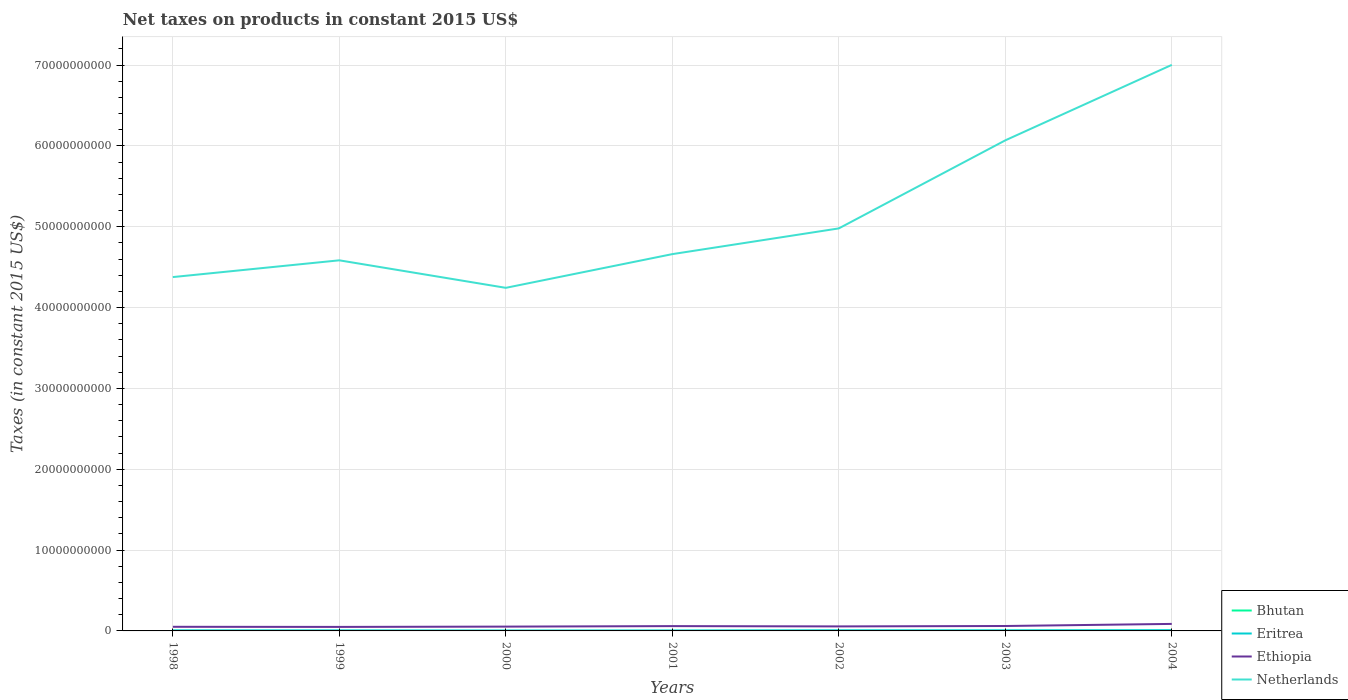How many different coloured lines are there?
Keep it short and to the point. 4. Is the number of lines equal to the number of legend labels?
Your response must be concise. Yes. Across all years, what is the maximum net taxes on products in Bhutan?
Keep it short and to the point. 9.43e+06. In which year was the net taxes on products in Ethiopia maximum?
Your answer should be compact. 1999. What is the total net taxes on products in Ethiopia in the graph?
Keep it short and to the point. 1.28e+07. What is the difference between the highest and the second highest net taxes on products in Ethiopia?
Your answer should be compact. 3.70e+08. What is the difference between the highest and the lowest net taxes on products in Eritrea?
Offer a very short reply. 3. Is the net taxes on products in Netherlands strictly greater than the net taxes on products in Eritrea over the years?
Give a very brief answer. No. How many lines are there?
Ensure brevity in your answer.  4. How many years are there in the graph?
Make the answer very short. 7. What is the difference between two consecutive major ticks on the Y-axis?
Your response must be concise. 1.00e+1. Are the values on the major ticks of Y-axis written in scientific E-notation?
Your response must be concise. No. Does the graph contain any zero values?
Ensure brevity in your answer.  No. How are the legend labels stacked?
Keep it short and to the point. Vertical. What is the title of the graph?
Ensure brevity in your answer.  Net taxes on products in constant 2015 US$. Does "Middle income" appear as one of the legend labels in the graph?
Your answer should be compact. No. What is the label or title of the X-axis?
Your answer should be very brief. Years. What is the label or title of the Y-axis?
Your answer should be very brief. Taxes (in constant 2015 US$). What is the Taxes (in constant 2015 US$) of Bhutan in 1998?
Your response must be concise. 1.32e+07. What is the Taxes (in constant 2015 US$) in Eritrea in 1998?
Offer a very short reply. 6.31e+07. What is the Taxes (in constant 2015 US$) in Ethiopia in 1998?
Provide a short and direct response. 5.10e+08. What is the Taxes (in constant 2015 US$) of Netherlands in 1998?
Make the answer very short. 4.38e+1. What is the Taxes (in constant 2015 US$) of Bhutan in 1999?
Your answer should be compact. 1.44e+07. What is the Taxes (in constant 2015 US$) in Eritrea in 1999?
Offer a very short reply. 5.98e+07. What is the Taxes (in constant 2015 US$) in Ethiopia in 1999?
Provide a succinct answer. 4.98e+08. What is the Taxes (in constant 2015 US$) of Netherlands in 1999?
Keep it short and to the point. 4.58e+1. What is the Taxes (in constant 2015 US$) of Bhutan in 2000?
Your answer should be very brief. 9.43e+06. What is the Taxes (in constant 2015 US$) of Eritrea in 2000?
Your response must be concise. 4.44e+07. What is the Taxes (in constant 2015 US$) of Ethiopia in 2000?
Provide a short and direct response. 5.34e+08. What is the Taxes (in constant 2015 US$) in Netherlands in 2000?
Provide a succinct answer. 4.24e+1. What is the Taxes (in constant 2015 US$) in Bhutan in 2001?
Provide a short and direct response. 1.02e+07. What is the Taxes (in constant 2015 US$) of Eritrea in 2001?
Make the answer very short. 5.02e+07. What is the Taxes (in constant 2015 US$) in Ethiopia in 2001?
Provide a short and direct response. 5.95e+08. What is the Taxes (in constant 2015 US$) of Netherlands in 2001?
Give a very brief answer. 4.66e+1. What is the Taxes (in constant 2015 US$) in Bhutan in 2002?
Provide a short and direct response. 1.68e+07. What is the Taxes (in constant 2015 US$) of Eritrea in 2002?
Offer a terse response. 7.06e+07. What is the Taxes (in constant 2015 US$) in Ethiopia in 2002?
Make the answer very short. 5.59e+08. What is the Taxes (in constant 2015 US$) in Netherlands in 2002?
Your response must be concise. 4.98e+1. What is the Taxes (in constant 2015 US$) in Bhutan in 2003?
Keep it short and to the point. 1.98e+07. What is the Taxes (in constant 2015 US$) of Eritrea in 2003?
Keep it short and to the point. 7.06e+07. What is the Taxes (in constant 2015 US$) of Ethiopia in 2003?
Make the answer very short. 6.09e+08. What is the Taxes (in constant 2015 US$) in Netherlands in 2003?
Offer a terse response. 6.07e+1. What is the Taxes (in constant 2015 US$) of Bhutan in 2004?
Offer a very short reply. 2.67e+07. What is the Taxes (in constant 2015 US$) of Eritrea in 2004?
Your answer should be compact. 8.94e+07. What is the Taxes (in constant 2015 US$) of Ethiopia in 2004?
Your response must be concise. 8.67e+08. What is the Taxes (in constant 2015 US$) of Netherlands in 2004?
Ensure brevity in your answer.  7.00e+1. Across all years, what is the maximum Taxes (in constant 2015 US$) of Bhutan?
Your response must be concise. 2.67e+07. Across all years, what is the maximum Taxes (in constant 2015 US$) in Eritrea?
Your response must be concise. 8.94e+07. Across all years, what is the maximum Taxes (in constant 2015 US$) in Ethiopia?
Keep it short and to the point. 8.67e+08. Across all years, what is the maximum Taxes (in constant 2015 US$) in Netherlands?
Provide a succinct answer. 7.00e+1. Across all years, what is the minimum Taxes (in constant 2015 US$) of Bhutan?
Provide a succinct answer. 9.43e+06. Across all years, what is the minimum Taxes (in constant 2015 US$) of Eritrea?
Provide a succinct answer. 4.44e+07. Across all years, what is the minimum Taxes (in constant 2015 US$) of Ethiopia?
Make the answer very short. 4.98e+08. Across all years, what is the minimum Taxes (in constant 2015 US$) of Netherlands?
Your answer should be very brief. 4.24e+1. What is the total Taxes (in constant 2015 US$) in Bhutan in the graph?
Your answer should be very brief. 1.11e+08. What is the total Taxes (in constant 2015 US$) in Eritrea in the graph?
Your answer should be very brief. 4.48e+08. What is the total Taxes (in constant 2015 US$) of Ethiopia in the graph?
Keep it short and to the point. 4.17e+09. What is the total Taxes (in constant 2015 US$) of Netherlands in the graph?
Make the answer very short. 3.59e+11. What is the difference between the Taxes (in constant 2015 US$) in Bhutan in 1998 and that in 1999?
Your answer should be compact. -1.19e+06. What is the difference between the Taxes (in constant 2015 US$) in Eritrea in 1998 and that in 1999?
Offer a very short reply. 3.34e+06. What is the difference between the Taxes (in constant 2015 US$) of Ethiopia in 1998 and that in 1999?
Provide a short and direct response. 1.28e+07. What is the difference between the Taxes (in constant 2015 US$) in Netherlands in 1998 and that in 1999?
Keep it short and to the point. -2.07e+09. What is the difference between the Taxes (in constant 2015 US$) in Bhutan in 1998 and that in 2000?
Provide a short and direct response. 3.80e+06. What is the difference between the Taxes (in constant 2015 US$) in Eritrea in 1998 and that in 2000?
Your answer should be compact. 1.87e+07. What is the difference between the Taxes (in constant 2015 US$) in Ethiopia in 1998 and that in 2000?
Keep it short and to the point. -2.34e+07. What is the difference between the Taxes (in constant 2015 US$) in Netherlands in 1998 and that in 2000?
Your response must be concise. 1.33e+09. What is the difference between the Taxes (in constant 2015 US$) in Bhutan in 1998 and that in 2001?
Ensure brevity in your answer.  3.06e+06. What is the difference between the Taxes (in constant 2015 US$) in Eritrea in 1998 and that in 2001?
Ensure brevity in your answer.  1.29e+07. What is the difference between the Taxes (in constant 2015 US$) of Ethiopia in 1998 and that in 2001?
Give a very brief answer. -8.50e+07. What is the difference between the Taxes (in constant 2015 US$) of Netherlands in 1998 and that in 2001?
Provide a short and direct response. -2.84e+09. What is the difference between the Taxes (in constant 2015 US$) of Bhutan in 1998 and that in 2002?
Offer a terse response. -3.53e+06. What is the difference between the Taxes (in constant 2015 US$) in Eritrea in 1998 and that in 2002?
Your answer should be compact. -7.46e+06. What is the difference between the Taxes (in constant 2015 US$) of Ethiopia in 1998 and that in 2002?
Give a very brief answer. -4.90e+07. What is the difference between the Taxes (in constant 2015 US$) in Netherlands in 1998 and that in 2002?
Give a very brief answer. -6.02e+09. What is the difference between the Taxes (in constant 2015 US$) in Bhutan in 1998 and that in 2003?
Your response must be concise. -6.53e+06. What is the difference between the Taxes (in constant 2015 US$) in Eritrea in 1998 and that in 2003?
Offer a terse response. -7.47e+06. What is the difference between the Taxes (in constant 2015 US$) of Ethiopia in 1998 and that in 2003?
Make the answer very short. -9.90e+07. What is the difference between the Taxes (in constant 2015 US$) of Netherlands in 1998 and that in 2003?
Your answer should be compact. -1.69e+1. What is the difference between the Taxes (in constant 2015 US$) in Bhutan in 1998 and that in 2004?
Your answer should be compact. -1.35e+07. What is the difference between the Taxes (in constant 2015 US$) of Eritrea in 1998 and that in 2004?
Ensure brevity in your answer.  -2.63e+07. What is the difference between the Taxes (in constant 2015 US$) in Ethiopia in 1998 and that in 2004?
Provide a short and direct response. -3.57e+08. What is the difference between the Taxes (in constant 2015 US$) of Netherlands in 1998 and that in 2004?
Give a very brief answer. -2.63e+1. What is the difference between the Taxes (in constant 2015 US$) in Bhutan in 1999 and that in 2000?
Keep it short and to the point. 4.99e+06. What is the difference between the Taxes (in constant 2015 US$) of Eritrea in 1999 and that in 2000?
Provide a succinct answer. 1.54e+07. What is the difference between the Taxes (in constant 2015 US$) of Ethiopia in 1999 and that in 2000?
Your response must be concise. -3.62e+07. What is the difference between the Taxes (in constant 2015 US$) of Netherlands in 1999 and that in 2000?
Make the answer very short. 3.40e+09. What is the difference between the Taxes (in constant 2015 US$) of Bhutan in 1999 and that in 2001?
Make the answer very short. 4.25e+06. What is the difference between the Taxes (in constant 2015 US$) of Eritrea in 1999 and that in 2001?
Keep it short and to the point. 9.56e+06. What is the difference between the Taxes (in constant 2015 US$) of Ethiopia in 1999 and that in 2001?
Provide a short and direct response. -9.77e+07. What is the difference between the Taxes (in constant 2015 US$) of Netherlands in 1999 and that in 2001?
Give a very brief answer. -7.67e+08. What is the difference between the Taxes (in constant 2015 US$) of Bhutan in 1999 and that in 2002?
Your answer should be very brief. -2.35e+06. What is the difference between the Taxes (in constant 2015 US$) of Eritrea in 1999 and that in 2002?
Provide a short and direct response. -1.08e+07. What is the difference between the Taxes (in constant 2015 US$) of Ethiopia in 1999 and that in 2002?
Your answer should be very brief. -6.17e+07. What is the difference between the Taxes (in constant 2015 US$) in Netherlands in 1999 and that in 2002?
Make the answer very short. -3.95e+09. What is the difference between the Taxes (in constant 2015 US$) in Bhutan in 1999 and that in 2003?
Your answer should be compact. -5.34e+06. What is the difference between the Taxes (in constant 2015 US$) in Eritrea in 1999 and that in 2003?
Keep it short and to the point. -1.08e+07. What is the difference between the Taxes (in constant 2015 US$) of Ethiopia in 1999 and that in 2003?
Offer a very short reply. -1.12e+08. What is the difference between the Taxes (in constant 2015 US$) of Netherlands in 1999 and that in 2003?
Your answer should be very brief. -1.48e+1. What is the difference between the Taxes (in constant 2015 US$) of Bhutan in 1999 and that in 2004?
Ensure brevity in your answer.  -1.23e+07. What is the difference between the Taxes (in constant 2015 US$) in Eritrea in 1999 and that in 2004?
Offer a very short reply. -2.96e+07. What is the difference between the Taxes (in constant 2015 US$) in Ethiopia in 1999 and that in 2004?
Provide a short and direct response. -3.70e+08. What is the difference between the Taxes (in constant 2015 US$) of Netherlands in 1999 and that in 2004?
Make the answer very short. -2.42e+1. What is the difference between the Taxes (in constant 2015 US$) in Bhutan in 2000 and that in 2001?
Make the answer very short. -7.45e+05. What is the difference between the Taxes (in constant 2015 US$) of Eritrea in 2000 and that in 2001?
Ensure brevity in your answer.  -5.80e+06. What is the difference between the Taxes (in constant 2015 US$) in Ethiopia in 2000 and that in 2001?
Keep it short and to the point. -6.16e+07. What is the difference between the Taxes (in constant 2015 US$) in Netherlands in 2000 and that in 2001?
Your answer should be very brief. -4.17e+09. What is the difference between the Taxes (in constant 2015 US$) of Bhutan in 2000 and that in 2002?
Make the answer very short. -7.34e+06. What is the difference between the Taxes (in constant 2015 US$) of Eritrea in 2000 and that in 2002?
Ensure brevity in your answer.  -2.62e+07. What is the difference between the Taxes (in constant 2015 US$) in Ethiopia in 2000 and that in 2002?
Your response must be concise. -2.56e+07. What is the difference between the Taxes (in constant 2015 US$) of Netherlands in 2000 and that in 2002?
Offer a terse response. -7.35e+09. What is the difference between the Taxes (in constant 2015 US$) in Bhutan in 2000 and that in 2003?
Offer a very short reply. -1.03e+07. What is the difference between the Taxes (in constant 2015 US$) in Eritrea in 2000 and that in 2003?
Your answer should be compact. -2.62e+07. What is the difference between the Taxes (in constant 2015 US$) in Ethiopia in 2000 and that in 2003?
Ensure brevity in your answer.  -7.56e+07. What is the difference between the Taxes (in constant 2015 US$) of Netherlands in 2000 and that in 2003?
Make the answer very short. -1.82e+1. What is the difference between the Taxes (in constant 2015 US$) of Bhutan in 2000 and that in 2004?
Make the answer very short. -1.73e+07. What is the difference between the Taxes (in constant 2015 US$) of Eritrea in 2000 and that in 2004?
Your answer should be compact. -4.50e+07. What is the difference between the Taxes (in constant 2015 US$) in Ethiopia in 2000 and that in 2004?
Provide a succinct answer. -3.34e+08. What is the difference between the Taxes (in constant 2015 US$) of Netherlands in 2000 and that in 2004?
Offer a terse response. -2.76e+1. What is the difference between the Taxes (in constant 2015 US$) of Bhutan in 2001 and that in 2002?
Your answer should be very brief. -6.59e+06. What is the difference between the Taxes (in constant 2015 US$) of Eritrea in 2001 and that in 2002?
Give a very brief answer. -2.04e+07. What is the difference between the Taxes (in constant 2015 US$) in Ethiopia in 2001 and that in 2002?
Your response must be concise. 3.60e+07. What is the difference between the Taxes (in constant 2015 US$) of Netherlands in 2001 and that in 2002?
Offer a very short reply. -3.18e+09. What is the difference between the Taxes (in constant 2015 US$) of Bhutan in 2001 and that in 2003?
Make the answer very short. -9.58e+06. What is the difference between the Taxes (in constant 2015 US$) of Eritrea in 2001 and that in 2003?
Offer a very short reply. -2.04e+07. What is the difference between the Taxes (in constant 2015 US$) in Ethiopia in 2001 and that in 2003?
Provide a succinct answer. -1.40e+07. What is the difference between the Taxes (in constant 2015 US$) in Netherlands in 2001 and that in 2003?
Ensure brevity in your answer.  -1.41e+1. What is the difference between the Taxes (in constant 2015 US$) in Bhutan in 2001 and that in 2004?
Ensure brevity in your answer.  -1.66e+07. What is the difference between the Taxes (in constant 2015 US$) in Eritrea in 2001 and that in 2004?
Your answer should be very brief. -3.92e+07. What is the difference between the Taxes (in constant 2015 US$) in Ethiopia in 2001 and that in 2004?
Provide a short and direct response. -2.72e+08. What is the difference between the Taxes (in constant 2015 US$) of Netherlands in 2001 and that in 2004?
Make the answer very short. -2.34e+1. What is the difference between the Taxes (in constant 2015 US$) of Bhutan in 2002 and that in 2003?
Provide a succinct answer. -2.99e+06. What is the difference between the Taxes (in constant 2015 US$) in Eritrea in 2002 and that in 2003?
Your answer should be compact. -1.22e+04. What is the difference between the Taxes (in constant 2015 US$) of Ethiopia in 2002 and that in 2003?
Offer a very short reply. -5.00e+07. What is the difference between the Taxes (in constant 2015 US$) in Netherlands in 2002 and that in 2003?
Give a very brief answer. -1.09e+1. What is the difference between the Taxes (in constant 2015 US$) of Bhutan in 2002 and that in 2004?
Offer a very short reply. -9.96e+06. What is the difference between the Taxes (in constant 2015 US$) of Eritrea in 2002 and that in 2004?
Your response must be concise. -1.88e+07. What is the difference between the Taxes (in constant 2015 US$) of Ethiopia in 2002 and that in 2004?
Provide a succinct answer. -3.08e+08. What is the difference between the Taxes (in constant 2015 US$) of Netherlands in 2002 and that in 2004?
Your answer should be very brief. -2.02e+1. What is the difference between the Taxes (in constant 2015 US$) in Bhutan in 2003 and that in 2004?
Keep it short and to the point. -6.97e+06. What is the difference between the Taxes (in constant 2015 US$) of Eritrea in 2003 and that in 2004?
Offer a terse response. -1.88e+07. What is the difference between the Taxes (in constant 2015 US$) of Ethiopia in 2003 and that in 2004?
Ensure brevity in your answer.  -2.58e+08. What is the difference between the Taxes (in constant 2015 US$) of Netherlands in 2003 and that in 2004?
Keep it short and to the point. -9.34e+09. What is the difference between the Taxes (in constant 2015 US$) in Bhutan in 1998 and the Taxes (in constant 2015 US$) in Eritrea in 1999?
Your answer should be very brief. -4.66e+07. What is the difference between the Taxes (in constant 2015 US$) in Bhutan in 1998 and the Taxes (in constant 2015 US$) in Ethiopia in 1999?
Keep it short and to the point. -4.84e+08. What is the difference between the Taxes (in constant 2015 US$) of Bhutan in 1998 and the Taxes (in constant 2015 US$) of Netherlands in 1999?
Offer a terse response. -4.58e+1. What is the difference between the Taxes (in constant 2015 US$) of Eritrea in 1998 and the Taxes (in constant 2015 US$) of Ethiopia in 1999?
Keep it short and to the point. -4.34e+08. What is the difference between the Taxes (in constant 2015 US$) of Eritrea in 1998 and the Taxes (in constant 2015 US$) of Netherlands in 1999?
Give a very brief answer. -4.58e+1. What is the difference between the Taxes (in constant 2015 US$) in Ethiopia in 1998 and the Taxes (in constant 2015 US$) in Netherlands in 1999?
Give a very brief answer. -4.53e+1. What is the difference between the Taxes (in constant 2015 US$) of Bhutan in 1998 and the Taxes (in constant 2015 US$) of Eritrea in 2000?
Keep it short and to the point. -3.12e+07. What is the difference between the Taxes (in constant 2015 US$) in Bhutan in 1998 and the Taxes (in constant 2015 US$) in Ethiopia in 2000?
Ensure brevity in your answer.  -5.21e+08. What is the difference between the Taxes (in constant 2015 US$) in Bhutan in 1998 and the Taxes (in constant 2015 US$) in Netherlands in 2000?
Your answer should be very brief. -4.24e+1. What is the difference between the Taxes (in constant 2015 US$) in Eritrea in 1998 and the Taxes (in constant 2015 US$) in Ethiopia in 2000?
Your answer should be compact. -4.71e+08. What is the difference between the Taxes (in constant 2015 US$) of Eritrea in 1998 and the Taxes (in constant 2015 US$) of Netherlands in 2000?
Your answer should be compact. -4.24e+1. What is the difference between the Taxes (in constant 2015 US$) in Ethiopia in 1998 and the Taxes (in constant 2015 US$) in Netherlands in 2000?
Offer a very short reply. -4.19e+1. What is the difference between the Taxes (in constant 2015 US$) in Bhutan in 1998 and the Taxes (in constant 2015 US$) in Eritrea in 2001?
Ensure brevity in your answer.  -3.70e+07. What is the difference between the Taxes (in constant 2015 US$) in Bhutan in 1998 and the Taxes (in constant 2015 US$) in Ethiopia in 2001?
Offer a very short reply. -5.82e+08. What is the difference between the Taxes (in constant 2015 US$) of Bhutan in 1998 and the Taxes (in constant 2015 US$) of Netherlands in 2001?
Make the answer very short. -4.66e+1. What is the difference between the Taxes (in constant 2015 US$) in Eritrea in 1998 and the Taxes (in constant 2015 US$) in Ethiopia in 2001?
Provide a short and direct response. -5.32e+08. What is the difference between the Taxes (in constant 2015 US$) in Eritrea in 1998 and the Taxes (in constant 2015 US$) in Netherlands in 2001?
Provide a succinct answer. -4.66e+1. What is the difference between the Taxes (in constant 2015 US$) of Ethiopia in 1998 and the Taxes (in constant 2015 US$) of Netherlands in 2001?
Give a very brief answer. -4.61e+1. What is the difference between the Taxes (in constant 2015 US$) in Bhutan in 1998 and the Taxes (in constant 2015 US$) in Eritrea in 2002?
Your response must be concise. -5.74e+07. What is the difference between the Taxes (in constant 2015 US$) in Bhutan in 1998 and the Taxes (in constant 2015 US$) in Ethiopia in 2002?
Give a very brief answer. -5.46e+08. What is the difference between the Taxes (in constant 2015 US$) of Bhutan in 1998 and the Taxes (in constant 2015 US$) of Netherlands in 2002?
Provide a short and direct response. -4.98e+1. What is the difference between the Taxes (in constant 2015 US$) of Eritrea in 1998 and the Taxes (in constant 2015 US$) of Ethiopia in 2002?
Offer a terse response. -4.96e+08. What is the difference between the Taxes (in constant 2015 US$) of Eritrea in 1998 and the Taxes (in constant 2015 US$) of Netherlands in 2002?
Provide a succinct answer. -4.97e+1. What is the difference between the Taxes (in constant 2015 US$) in Ethiopia in 1998 and the Taxes (in constant 2015 US$) in Netherlands in 2002?
Offer a terse response. -4.93e+1. What is the difference between the Taxes (in constant 2015 US$) of Bhutan in 1998 and the Taxes (in constant 2015 US$) of Eritrea in 2003?
Keep it short and to the point. -5.74e+07. What is the difference between the Taxes (in constant 2015 US$) in Bhutan in 1998 and the Taxes (in constant 2015 US$) in Ethiopia in 2003?
Give a very brief answer. -5.96e+08. What is the difference between the Taxes (in constant 2015 US$) in Bhutan in 1998 and the Taxes (in constant 2015 US$) in Netherlands in 2003?
Give a very brief answer. -6.07e+1. What is the difference between the Taxes (in constant 2015 US$) of Eritrea in 1998 and the Taxes (in constant 2015 US$) of Ethiopia in 2003?
Your answer should be very brief. -5.46e+08. What is the difference between the Taxes (in constant 2015 US$) in Eritrea in 1998 and the Taxes (in constant 2015 US$) in Netherlands in 2003?
Ensure brevity in your answer.  -6.06e+1. What is the difference between the Taxes (in constant 2015 US$) of Ethiopia in 1998 and the Taxes (in constant 2015 US$) of Netherlands in 2003?
Your answer should be very brief. -6.02e+1. What is the difference between the Taxes (in constant 2015 US$) in Bhutan in 1998 and the Taxes (in constant 2015 US$) in Eritrea in 2004?
Give a very brief answer. -7.62e+07. What is the difference between the Taxes (in constant 2015 US$) of Bhutan in 1998 and the Taxes (in constant 2015 US$) of Ethiopia in 2004?
Keep it short and to the point. -8.54e+08. What is the difference between the Taxes (in constant 2015 US$) in Bhutan in 1998 and the Taxes (in constant 2015 US$) in Netherlands in 2004?
Provide a short and direct response. -7.00e+1. What is the difference between the Taxes (in constant 2015 US$) in Eritrea in 1998 and the Taxes (in constant 2015 US$) in Ethiopia in 2004?
Keep it short and to the point. -8.04e+08. What is the difference between the Taxes (in constant 2015 US$) in Eritrea in 1998 and the Taxes (in constant 2015 US$) in Netherlands in 2004?
Provide a short and direct response. -7.00e+1. What is the difference between the Taxes (in constant 2015 US$) in Ethiopia in 1998 and the Taxes (in constant 2015 US$) in Netherlands in 2004?
Offer a terse response. -6.95e+1. What is the difference between the Taxes (in constant 2015 US$) of Bhutan in 1999 and the Taxes (in constant 2015 US$) of Eritrea in 2000?
Your answer should be very brief. -3.00e+07. What is the difference between the Taxes (in constant 2015 US$) of Bhutan in 1999 and the Taxes (in constant 2015 US$) of Ethiopia in 2000?
Provide a short and direct response. -5.19e+08. What is the difference between the Taxes (in constant 2015 US$) in Bhutan in 1999 and the Taxes (in constant 2015 US$) in Netherlands in 2000?
Your response must be concise. -4.24e+1. What is the difference between the Taxes (in constant 2015 US$) in Eritrea in 1999 and the Taxes (in constant 2015 US$) in Ethiopia in 2000?
Offer a terse response. -4.74e+08. What is the difference between the Taxes (in constant 2015 US$) in Eritrea in 1999 and the Taxes (in constant 2015 US$) in Netherlands in 2000?
Offer a terse response. -4.24e+1. What is the difference between the Taxes (in constant 2015 US$) in Ethiopia in 1999 and the Taxes (in constant 2015 US$) in Netherlands in 2000?
Provide a short and direct response. -4.19e+1. What is the difference between the Taxes (in constant 2015 US$) in Bhutan in 1999 and the Taxes (in constant 2015 US$) in Eritrea in 2001?
Provide a short and direct response. -3.58e+07. What is the difference between the Taxes (in constant 2015 US$) of Bhutan in 1999 and the Taxes (in constant 2015 US$) of Ethiopia in 2001?
Offer a very short reply. -5.81e+08. What is the difference between the Taxes (in constant 2015 US$) of Bhutan in 1999 and the Taxes (in constant 2015 US$) of Netherlands in 2001?
Provide a short and direct response. -4.66e+1. What is the difference between the Taxes (in constant 2015 US$) in Eritrea in 1999 and the Taxes (in constant 2015 US$) in Ethiopia in 2001?
Offer a very short reply. -5.36e+08. What is the difference between the Taxes (in constant 2015 US$) of Eritrea in 1999 and the Taxes (in constant 2015 US$) of Netherlands in 2001?
Offer a very short reply. -4.66e+1. What is the difference between the Taxes (in constant 2015 US$) of Ethiopia in 1999 and the Taxes (in constant 2015 US$) of Netherlands in 2001?
Give a very brief answer. -4.61e+1. What is the difference between the Taxes (in constant 2015 US$) of Bhutan in 1999 and the Taxes (in constant 2015 US$) of Eritrea in 2002?
Your response must be concise. -5.62e+07. What is the difference between the Taxes (in constant 2015 US$) of Bhutan in 1999 and the Taxes (in constant 2015 US$) of Ethiopia in 2002?
Your answer should be very brief. -5.45e+08. What is the difference between the Taxes (in constant 2015 US$) of Bhutan in 1999 and the Taxes (in constant 2015 US$) of Netherlands in 2002?
Your answer should be very brief. -4.98e+1. What is the difference between the Taxes (in constant 2015 US$) of Eritrea in 1999 and the Taxes (in constant 2015 US$) of Ethiopia in 2002?
Offer a very short reply. -5.00e+08. What is the difference between the Taxes (in constant 2015 US$) in Eritrea in 1999 and the Taxes (in constant 2015 US$) in Netherlands in 2002?
Your answer should be compact. -4.97e+1. What is the difference between the Taxes (in constant 2015 US$) in Ethiopia in 1999 and the Taxes (in constant 2015 US$) in Netherlands in 2002?
Your response must be concise. -4.93e+1. What is the difference between the Taxes (in constant 2015 US$) of Bhutan in 1999 and the Taxes (in constant 2015 US$) of Eritrea in 2003?
Offer a terse response. -5.62e+07. What is the difference between the Taxes (in constant 2015 US$) of Bhutan in 1999 and the Taxes (in constant 2015 US$) of Ethiopia in 2003?
Your answer should be compact. -5.95e+08. What is the difference between the Taxes (in constant 2015 US$) of Bhutan in 1999 and the Taxes (in constant 2015 US$) of Netherlands in 2003?
Offer a terse response. -6.07e+1. What is the difference between the Taxes (in constant 2015 US$) of Eritrea in 1999 and the Taxes (in constant 2015 US$) of Ethiopia in 2003?
Keep it short and to the point. -5.49e+08. What is the difference between the Taxes (in constant 2015 US$) of Eritrea in 1999 and the Taxes (in constant 2015 US$) of Netherlands in 2003?
Provide a succinct answer. -6.06e+1. What is the difference between the Taxes (in constant 2015 US$) in Ethiopia in 1999 and the Taxes (in constant 2015 US$) in Netherlands in 2003?
Your response must be concise. -6.02e+1. What is the difference between the Taxes (in constant 2015 US$) of Bhutan in 1999 and the Taxes (in constant 2015 US$) of Eritrea in 2004?
Ensure brevity in your answer.  -7.50e+07. What is the difference between the Taxes (in constant 2015 US$) of Bhutan in 1999 and the Taxes (in constant 2015 US$) of Ethiopia in 2004?
Offer a very short reply. -8.53e+08. What is the difference between the Taxes (in constant 2015 US$) of Bhutan in 1999 and the Taxes (in constant 2015 US$) of Netherlands in 2004?
Offer a terse response. -7.00e+1. What is the difference between the Taxes (in constant 2015 US$) in Eritrea in 1999 and the Taxes (in constant 2015 US$) in Ethiopia in 2004?
Offer a terse response. -8.08e+08. What is the difference between the Taxes (in constant 2015 US$) in Eritrea in 1999 and the Taxes (in constant 2015 US$) in Netherlands in 2004?
Make the answer very short. -7.00e+1. What is the difference between the Taxes (in constant 2015 US$) in Ethiopia in 1999 and the Taxes (in constant 2015 US$) in Netherlands in 2004?
Give a very brief answer. -6.95e+1. What is the difference between the Taxes (in constant 2015 US$) in Bhutan in 2000 and the Taxes (in constant 2015 US$) in Eritrea in 2001?
Provide a succinct answer. -4.08e+07. What is the difference between the Taxes (in constant 2015 US$) of Bhutan in 2000 and the Taxes (in constant 2015 US$) of Ethiopia in 2001?
Keep it short and to the point. -5.86e+08. What is the difference between the Taxes (in constant 2015 US$) in Bhutan in 2000 and the Taxes (in constant 2015 US$) in Netherlands in 2001?
Keep it short and to the point. -4.66e+1. What is the difference between the Taxes (in constant 2015 US$) of Eritrea in 2000 and the Taxes (in constant 2015 US$) of Ethiopia in 2001?
Your answer should be very brief. -5.51e+08. What is the difference between the Taxes (in constant 2015 US$) in Eritrea in 2000 and the Taxes (in constant 2015 US$) in Netherlands in 2001?
Offer a terse response. -4.66e+1. What is the difference between the Taxes (in constant 2015 US$) of Ethiopia in 2000 and the Taxes (in constant 2015 US$) of Netherlands in 2001?
Offer a very short reply. -4.61e+1. What is the difference between the Taxes (in constant 2015 US$) of Bhutan in 2000 and the Taxes (in constant 2015 US$) of Eritrea in 2002?
Your answer should be very brief. -6.12e+07. What is the difference between the Taxes (in constant 2015 US$) in Bhutan in 2000 and the Taxes (in constant 2015 US$) in Ethiopia in 2002?
Offer a very short reply. -5.50e+08. What is the difference between the Taxes (in constant 2015 US$) of Bhutan in 2000 and the Taxes (in constant 2015 US$) of Netherlands in 2002?
Your answer should be compact. -4.98e+1. What is the difference between the Taxes (in constant 2015 US$) of Eritrea in 2000 and the Taxes (in constant 2015 US$) of Ethiopia in 2002?
Provide a short and direct response. -5.15e+08. What is the difference between the Taxes (in constant 2015 US$) in Eritrea in 2000 and the Taxes (in constant 2015 US$) in Netherlands in 2002?
Give a very brief answer. -4.98e+1. What is the difference between the Taxes (in constant 2015 US$) in Ethiopia in 2000 and the Taxes (in constant 2015 US$) in Netherlands in 2002?
Make the answer very short. -4.93e+1. What is the difference between the Taxes (in constant 2015 US$) of Bhutan in 2000 and the Taxes (in constant 2015 US$) of Eritrea in 2003?
Your answer should be compact. -6.12e+07. What is the difference between the Taxes (in constant 2015 US$) in Bhutan in 2000 and the Taxes (in constant 2015 US$) in Ethiopia in 2003?
Provide a short and direct response. -6.00e+08. What is the difference between the Taxes (in constant 2015 US$) of Bhutan in 2000 and the Taxes (in constant 2015 US$) of Netherlands in 2003?
Offer a very short reply. -6.07e+1. What is the difference between the Taxes (in constant 2015 US$) in Eritrea in 2000 and the Taxes (in constant 2015 US$) in Ethiopia in 2003?
Your answer should be compact. -5.65e+08. What is the difference between the Taxes (in constant 2015 US$) of Eritrea in 2000 and the Taxes (in constant 2015 US$) of Netherlands in 2003?
Keep it short and to the point. -6.06e+1. What is the difference between the Taxes (in constant 2015 US$) in Ethiopia in 2000 and the Taxes (in constant 2015 US$) in Netherlands in 2003?
Provide a short and direct response. -6.02e+1. What is the difference between the Taxes (in constant 2015 US$) of Bhutan in 2000 and the Taxes (in constant 2015 US$) of Eritrea in 2004?
Offer a terse response. -8.00e+07. What is the difference between the Taxes (in constant 2015 US$) of Bhutan in 2000 and the Taxes (in constant 2015 US$) of Ethiopia in 2004?
Ensure brevity in your answer.  -8.58e+08. What is the difference between the Taxes (in constant 2015 US$) in Bhutan in 2000 and the Taxes (in constant 2015 US$) in Netherlands in 2004?
Provide a short and direct response. -7.00e+1. What is the difference between the Taxes (in constant 2015 US$) of Eritrea in 2000 and the Taxes (in constant 2015 US$) of Ethiopia in 2004?
Offer a terse response. -8.23e+08. What is the difference between the Taxes (in constant 2015 US$) of Eritrea in 2000 and the Taxes (in constant 2015 US$) of Netherlands in 2004?
Provide a short and direct response. -7.00e+1. What is the difference between the Taxes (in constant 2015 US$) of Ethiopia in 2000 and the Taxes (in constant 2015 US$) of Netherlands in 2004?
Offer a terse response. -6.95e+1. What is the difference between the Taxes (in constant 2015 US$) in Bhutan in 2001 and the Taxes (in constant 2015 US$) in Eritrea in 2002?
Your answer should be very brief. -6.04e+07. What is the difference between the Taxes (in constant 2015 US$) in Bhutan in 2001 and the Taxes (in constant 2015 US$) in Ethiopia in 2002?
Offer a very short reply. -5.49e+08. What is the difference between the Taxes (in constant 2015 US$) of Bhutan in 2001 and the Taxes (in constant 2015 US$) of Netherlands in 2002?
Offer a terse response. -4.98e+1. What is the difference between the Taxes (in constant 2015 US$) of Eritrea in 2001 and the Taxes (in constant 2015 US$) of Ethiopia in 2002?
Offer a terse response. -5.09e+08. What is the difference between the Taxes (in constant 2015 US$) in Eritrea in 2001 and the Taxes (in constant 2015 US$) in Netherlands in 2002?
Offer a very short reply. -4.97e+1. What is the difference between the Taxes (in constant 2015 US$) of Ethiopia in 2001 and the Taxes (in constant 2015 US$) of Netherlands in 2002?
Offer a very short reply. -4.92e+1. What is the difference between the Taxes (in constant 2015 US$) of Bhutan in 2001 and the Taxes (in constant 2015 US$) of Eritrea in 2003?
Offer a terse response. -6.04e+07. What is the difference between the Taxes (in constant 2015 US$) in Bhutan in 2001 and the Taxes (in constant 2015 US$) in Ethiopia in 2003?
Your response must be concise. -5.99e+08. What is the difference between the Taxes (in constant 2015 US$) of Bhutan in 2001 and the Taxes (in constant 2015 US$) of Netherlands in 2003?
Keep it short and to the point. -6.07e+1. What is the difference between the Taxes (in constant 2015 US$) of Eritrea in 2001 and the Taxes (in constant 2015 US$) of Ethiopia in 2003?
Ensure brevity in your answer.  -5.59e+08. What is the difference between the Taxes (in constant 2015 US$) of Eritrea in 2001 and the Taxes (in constant 2015 US$) of Netherlands in 2003?
Offer a very short reply. -6.06e+1. What is the difference between the Taxes (in constant 2015 US$) of Ethiopia in 2001 and the Taxes (in constant 2015 US$) of Netherlands in 2003?
Provide a succinct answer. -6.01e+1. What is the difference between the Taxes (in constant 2015 US$) of Bhutan in 2001 and the Taxes (in constant 2015 US$) of Eritrea in 2004?
Ensure brevity in your answer.  -7.93e+07. What is the difference between the Taxes (in constant 2015 US$) in Bhutan in 2001 and the Taxes (in constant 2015 US$) in Ethiopia in 2004?
Your answer should be very brief. -8.57e+08. What is the difference between the Taxes (in constant 2015 US$) of Bhutan in 2001 and the Taxes (in constant 2015 US$) of Netherlands in 2004?
Your answer should be very brief. -7.00e+1. What is the difference between the Taxes (in constant 2015 US$) in Eritrea in 2001 and the Taxes (in constant 2015 US$) in Ethiopia in 2004?
Give a very brief answer. -8.17e+08. What is the difference between the Taxes (in constant 2015 US$) in Eritrea in 2001 and the Taxes (in constant 2015 US$) in Netherlands in 2004?
Your answer should be very brief. -7.00e+1. What is the difference between the Taxes (in constant 2015 US$) of Ethiopia in 2001 and the Taxes (in constant 2015 US$) of Netherlands in 2004?
Provide a succinct answer. -6.94e+1. What is the difference between the Taxes (in constant 2015 US$) in Bhutan in 2002 and the Taxes (in constant 2015 US$) in Eritrea in 2003?
Your answer should be compact. -5.38e+07. What is the difference between the Taxes (in constant 2015 US$) in Bhutan in 2002 and the Taxes (in constant 2015 US$) in Ethiopia in 2003?
Offer a terse response. -5.93e+08. What is the difference between the Taxes (in constant 2015 US$) in Bhutan in 2002 and the Taxes (in constant 2015 US$) in Netherlands in 2003?
Offer a very short reply. -6.07e+1. What is the difference between the Taxes (in constant 2015 US$) of Eritrea in 2002 and the Taxes (in constant 2015 US$) of Ethiopia in 2003?
Ensure brevity in your answer.  -5.39e+08. What is the difference between the Taxes (in constant 2015 US$) of Eritrea in 2002 and the Taxes (in constant 2015 US$) of Netherlands in 2003?
Provide a short and direct response. -6.06e+1. What is the difference between the Taxes (in constant 2015 US$) in Ethiopia in 2002 and the Taxes (in constant 2015 US$) in Netherlands in 2003?
Give a very brief answer. -6.01e+1. What is the difference between the Taxes (in constant 2015 US$) in Bhutan in 2002 and the Taxes (in constant 2015 US$) in Eritrea in 2004?
Keep it short and to the point. -7.27e+07. What is the difference between the Taxes (in constant 2015 US$) in Bhutan in 2002 and the Taxes (in constant 2015 US$) in Ethiopia in 2004?
Give a very brief answer. -8.51e+08. What is the difference between the Taxes (in constant 2015 US$) in Bhutan in 2002 and the Taxes (in constant 2015 US$) in Netherlands in 2004?
Offer a terse response. -7.00e+1. What is the difference between the Taxes (in constant 2015 US$) in Eritrea in 2002 and the Taxes (in constant 2015 US$) in Ethiopia in 2004?
Your answer should be very brief. -7.97e+08. What is the difference between the Taxes (in constant 2015 US$) in Eritrea in 2002 and the Taxes (in constant 2015 US$) in Netherlands in 2004?
Your response must be concise. -7.00e+1. What is the difference between the Taxes (in constant 2015 US$) in Ethiopia in 2002 and the Taxes (in constant 2015 US$) in Netherlands in 2004?
Provide a succinct answer. -6.95e+1. What is the difference between the Taxes (in constant 2015 US$) of Bhutan in 2003 and the Taxes (in constant 2015 US$) of Eritrea in 2004?
Your response must be concise. -6.97e+07. What is the difference between the Taxes (in constant 2015 US$) in Bhutan in 2003 and the Taxes (in constant 2015 US$) in Ethiopia in 2004?
Give a very brief answer. -8.48e+08. What is the difference between the Taxes (in constant 2015 US$) in Bhutan in 2003 and the Taxes (in constant 2015 US$) in Netherlands in 2004?
Offer a very short reply. -7.00e+1. What is the difference between the Taxes (in constant 2015 US$) in Eritrea in 2003 and the Taxes (in constant 2015 US$) in Ethiopia in 2004?
Your response must be concise. -7.97e+08. What is the difference between the Taxes (in constant 2015 US$) of Eritrea in 2003 and the Taxes (in constant 2015 US$) of Netherlands in 2004?
Your answer should be compact. -7.00e+1. What is the difference between the Taxes (in constant 2015 US$) of Ethiopia in 2003 and the Taxes (in constant 2015 US$) of Netherlands in 2004?
Ensure brevity in your answer.  -6.94e+1. What is the average Taxes (in constant 2015 US$) of Bhutan per year?
Your answer should be compact. 1.58e+07. What is the average Taxes (in constant 2015 US$) of Eritrea per year?
Your answer should be very brief. 6.40e+07. What is the average Taxes (in constant 2015 US$) of Ethiopia per year?
Offer a terse response. 5.96e+08. What is the average Taxes (in constant 2015 US$) of Netherlands per year?
Give a very brief answer. 5.13e+1. In the year 1998, what is the difference between the Taxes (in constant 2015 US$) in Bhutan and Taxes (in constant 2015 US$) in Eritrea?
Your answer should be very brief. -4.99e+07. In the year 1998, what is the difference between the Taxes (in constant 2015 US$) in Bhutan and Taxes (in constant 2015 US$) in Ethiopia?
Your answer should be very brief. -4.97e+08. In the year 1998, what is the difference between the Taxes (in constant 2015 US$) of Bhutan and Taxes (in constant 2015 US$) of Netherlands?
Provide a short and direct response. -4.38e+1. In the year 1998, what is the difference between the Taxes (in constant 2015 US$) in Eritrea and Taxes (in constant 2015 US$) in Ethiopia?
Keep it short and to the point. -4.47e+08. In the year 1998, what is the difference between the Taxes (in constant 2015 US$) of Eritrea and Taxes (in constant 2015 US$) of Netherlands?
Provide a succinct answer. -4.37e+1. In the year 1998, what is the difference between the Taxes (in constant 2015 US$) in Ethiopia and Taxes (in constant 2015 US$) in Netherlands?
Your answer should be compact. -4.33e+1. In the year 1999, what is the difference between the Taxes (in constant 2015 US$) of Bhutan and Taxes (in constant 2015 US$) of Eritrea?
Your answer should be very brief. -4.54e+07. In the year 1999, what is the difference between the Taxes (in constant 2015 US$) of Bhutan and Taxes (in constant 2015 US$) of Ethiopia?
Offer a terse response. -4.83e+08. In the year 1999, what is the difference between the Taxes (in constant 2015 US$) in Bhutan and Taxes (in constant 2015 US$) in Netherlands?
Your response must be concise. -4.58e+1. In the year 1999, what is the difference between the Taxes (in constant 2015 US$) of Eritrea and Taxes (in constant 2015 US$) of Ethiopia?
Provide a short and direct response. -4.38e+08. In the year 1999, what is the difference between the Taxes (in constant 2015 US$) of Eritrea and Taxes (in constant 2015 US$) of Netherlands?
Offer a terse response. -4.58e+1. In the year 1999, what is the difference between the Taxes (in constant 2015 US$) in Ethiopia and Taxes (in constant 2015 US$) in Netherlands?
Your answer should be very brief. -4.54e+1. In the year 2000, what is the difference between the Taxes (in constant 2015 US$) of Bhutan and Taxes (in constant 2015 US$) of Eritrea?
Provide a short and direct response. -3.50e+07. In the year 2000, what is the difference between the Taxes (in constant 2015 US$) in Bhutan and Taxes (in constant 2015 US$) in Ethiopia?
Give a very brief answer. -5.24e+08. In the year 2000, what is the difference between the Taxes (in constant 2015 US$) of Bhutan and Taxes (in constant 2015 US$) of Netherlands?
Give a very brief answer. -4.24e+1. In the year 2000, what is the difference between the Taxes (in constant 2015 US$) in Eritrea and Taxes (in constant 2015 US$) in Ethiopia?
Offer a very short reply. -4.89e+08. In the year 2000, what is the difference between the Taxes (in constant 2015 US$) of Eritrea and Taxes (in constant 2015 US$) of Netherlands?
Provide a succinct answer. -4.24e+1. In the year 2000, what is the difference between the Taxes (in constant 2015 US$) of Ethiopia and Taxes (in constant 2015 US$) of Netherlands?
Your answer should be compact. -4.19e+1. In the year 2001, what is the difference between the Taxes (in constant 2015 US$) of Bhutan and Taxes (in constant 2015 US$) of Eritrea?
Make the answer very short. -4.01e+07. In the year 2001, what is the difference between the Taxes (in constant 2015 US$) of Bhutan and Taxes (in constant 2015 US$) of Ethiopia?
Make the answer very short. -5.85e+08. In the year 2001, what is the difference between the Taxes (in constant 2015 US$) in Bhutan and Taxes (in constant 2015 US$) in Netherlands?
Your answer should be compact. -4.66e+1. In the year 2001, what is the difference between the Taxes (in constant 2015 US$) in Eritrea and Taxes (in constant 2015 US$) in Ethiopia?
Offer a very short reply. -5.45e+08. In the year 2001, what is the difference between the Taxes (in constant 2015 US$) of Eritrea and Taxes (in constant 2015 US$) of Netherlands?
Provide a succinct answer. -4.66e+1. In the year 2001, what is the difference between the Taxes (in constant 2015 US$) in Ethiopia and Taxes (in constant 2015 US$) in Netherlands?
Provide a short and direct response. -4.60e+1. In the year 2002, what is the difference between the Taxes (in constant 2015 US$) in Bhutan and Taxes (in constant 2015 US$) in Eritrea?
Your response must be concise. -5.38e+07. In the year 2002, what is the difference between the Taxes (in constant 2015 US$) of Bhutan and Taxes (in constant 2015 US$) of Ethiopia?
Your answer should be very brief. -5.43e+08. In the year 2002, what is the difference between the Taxes (in constant 2015 US$) in Bhutan and Taxes (in constant 2015 US$) in Netherlands?
Ensure brevity in your answer.  -4.98e+1. In the year 2002, what is the difference between the Taxes (in constant 2015 US$) in Eritrea and Taxes (in constant 2015 US$) in Ethiopia?
Your answer should be very brief. -4.89e+08. In the year 2002, what is the difference between the Taxes (in constant 2015 US$) in Eritrea and Taxes (in constant 2015 US$) in Netherlands?
Provide a short and direct response. -4.97e+1. In the year 2002, what is the difference between the Taxes (in constant 2015 US$) of Ethiopia and Taxes (in constant 2015 US$) of Netherlands?
Ensure brevity in your answer.  -4.92e+1. In the year 2003, what is the difference between the Taxes (in constant 2015 US$) of Bhutan and Taxes (in constant 2015 US$) of Eritrea?
Offer a very short reply. -5.08e+07. In the year 2003, what is the difference between the Taxes (in constant 2015 US$) of Bhutan and Taxes (in constant 2015 US$) of Ethiopia?
Give a very brief answer. -5.90e+08. In the year 2003, what is the difference between the Taxes (in constant 2015 US$) of Bhutan and Taxes (in constant 2015 US$) of Netherlands?
Keep it short and to the point. -6.07e+1. In the year 2003, what is the difference between the Taxes (in constant 2015 US$) of Eritrea and Taxes (in constant 2015 US$) of Ethiopia?
Your answer should be very brief. -5.39e+08. In the year 2003, what is the difference between the Taxes (in constant 2015 US$) in Eritrea and Taxes (in constant 2015 US$) in Netherlands?
Provide a short and direct response. -6.06e+1. In the year 2003, what is the difference between the Taxes (in constant 2015 US$) of Ethiopia and Taxes (in constant 2015 US$) of Netherlands?
Your response must be concise. -6.01e+1. In the year 2004, what is the difference between the Taxes (in constant 2015 US$) of Bhutan and Taxes (in constant 2015 US$) of Eritrea?
Offer a very short reply. -6.27e+07. In the year 2004, what is the difference between the Taxes (in constant 2015 US$) of Bhutan and Taxes (in constant 2015 US$) of Ethiopia?
Provide a succinct answer. -8.41e+08. In the year 2004, what is the difference between the Taxes (in constant 2015 US$) in Bhutan and Taxes (in constant 2015 US$) in Netherlands?
Offer a terse response. -7.00e+1. In the year 2004, what is the difference between the Taxes (in constant 2015 US$) of Eritrea and Taxes (in constant 2015 US$) of Ethiopia?
Offer a terse response. -7.78e+08. In the year 2004, what is the difference between the Taxes (in constant 2015 US$) in Eritrea and Taxes (in constant 2015 US$) in Netherlands?
Make the answer very short. -6.99e+1. In the year 2004, what is the difference between the Taxes (in constant 2015 US$) in Ethiopia and Taxes (in constant 2015 US$) in Netherlands?
Offer a very short reply. -6.92e+1. What is the ratio of the Taxes (in constant 2015 US$) of Bhutan in 1998 to that in 1999?
Ensure brevity in your answer.  0.92. What is the ratio of the Taxes (in constant 2015 US$) of Eritrea in 1998 to that in 1999?
Keep it short and to the point. 1.06. What is the ratio of the Taxes (in constant 2015 US$) of Ethiopia in 1998 to that in 1999?
Offer a very short reply. 1.03. What is the ratio of the Taxes (in constant 2015 US$) of Netherlands in 1998 to that in 1999?
Provide a short and direct response. 0.95. What is the ratio of the Taxes (in constant 2015 US$) in Bhutan in 1998 to that in 2000?
Ensure brevity in your answer.  1.4. What is the ratio of the Taxes (in constant 2015 US$) of Eritrea in 1998 to that in 2000?
Provide a succinct answer. 1.42. What is the ratio of the Taxes (in constant 2015 US$) of Ethiopia in 1998 to that in 2000?
Your answer should be very brief. 0.96. What is the ratio of the Taxes (in constant 2015 US$) in Netherlands in 1998 to that in 2000?
Your answer should be very brief. 1.03. What is the ratio of the Taxes (in constant 2015 US$) of Bhutan in 1998 to that in 2001?
Your response must be concise. 1.3. What is the ratio of the Taxes (in constant 2015 US$) of Eritrea in 1998 to that in 2001?
Your answer should be compact. 1.26. What is the ratio of the Taxes (in constant 2015 US$) of Ethiopia in 1998 to that in 2001?
Give a very brief answer. 0.86. What is the ratio of the Taxes (in constant 2015 US$) of Netherlands in 1998 to that in 2001?
Make the answer very short. 0.94. What is the ratio of the Taxes (in constant 2015 US$) of Bhutan in 1998 to that in 2002?
Give a very brief answer. 0.79. What is the ratio of the Taxes (in constant 2015 US$) in Eritrea in 1998 to that in 2002?
Provide a succinct answer. 0.89. What is the ratio of the Taxes (in constant 2015 US$) in Ethiopia in 1998 to that in 2002?
Your answer should be compact. 0.91. What is the ratio of the Taxes (in constant 2015 US$) of Netherlands in 1998 to that in 2002?
Your response must be concise. 0.88. What is the ratio of the Taxes (in constant 2015 US$) of Bhutan in 1998 to that in 2003?
Provide a short and direct response. 0.67. What is the ratio of the Taxes (in constant 2015 US$) of Eritrea in 1998 to that in 2003?
Your answer should be compact. 0.89. What is the ratio of the Taxes (in constant 2015 US$) of Ethiopia in 1998 to that in 2003?
Offer a terse response. 0.84. What is the ratio of the Taxes (in constant 2015 US$) of Netherlands in 1998 to that in 2003?
Your answer should be compact. 0.72. What is the ratio of the Taxes (in constant 2015 US$) of Bhutan in 1998 to that in 2004?
Provide a succinct answer. 0.5. What is the ratio of the Taxes (in constant 2015 US$) of Eritrea in 1998 to that in 2004?
Offer a terse response. 0.71. What is the ratio of the Taxes (in constant 2015 US$) in Ethiopia in 1998 to that in 2004?
Your response must be concise. 0.59. What is the ratio of the Taxes (in constant 2015 US$) in Netherlands in 1998 to that in 2004?
Offer a very short reply. 0.63. What is the ratio of the Taxes (in constant 2015 US$) of Bhutan in 1999 to that in 2000?
Provide a short and direct response. 1.53. What is the ratio of the Taxes (in constant 2015 US$) in Eritrea in 1999 to that in 2000?
Make the answer very short. 1.35. What is the ratio of the Taxes (in constant 2015 US$) of Ethiopia in 1999 to that in 2000?
Offer a terse response. 0.93. What is the ratio of the Taxes (in constant 2015 US$) of Netherlands in 1999 to that in 2000?
Ensure brevity in your answer.  1.08. What is the ratio of the Taxes (in constant 2015 US$) in Bhutan in 1999 to that in 2001?
Provide a succinct answer. 1.42. What is the ratio of the Taxes (in constant 2015 US$) in Eritrea in 1999 to that in 2001?
Make the answer very short. 1.19. What is the ratio of the Taxes (in constant 2015 US$) of Ethiopia in 1999 to that in 2001?
Your answer should be compact. 0.84. What is the ratio of the Taxes (in constant 2015 US$) of Netherlands in 1999 to that in 2001?
Give a very brief answer. 0.98. What is the ratio of the Taxes (in constant 2015 US$) in Bhutan in 1999 to that in 2002?
Keep it short and to the point. 0.86. What is the ratio of the Taxes (in constant 2015 US$) of Eritrea in 1999 to that in 2002?
Ensure brevity in your answer.  0.85. What is the ratio of the Taxes (in constant 2015 US$) of Ethiopia in 1999 to that in 2002?
Your response must be concise. 0.89. What is the ratio of the Taxes (in constant 2015 US$) in Netherlands in 1999 to that in 2002?
Give a very brief answer. 0.92. What is the ratio of the Taxes (in constant 2015 US$) of Bhutan in 1999 to that in 2003?
Offer a very short reply. 0.73. What is the ratio of the Taxes (in constant 2015 US$) in Eritrea in 1999 to that in 2003?
Provide a short and direct response. 0.85. What is the ratio of the Taxes (in constant 2015 US$) in Ethiopia in 1999 to that in 2003?
Give a very brief answer. 0.82. What is the ratio of the Taxes (in constant 2015 US$) of Netherlands in 1999 to that in 2003?
Offer a terse response. 0.76. What is the ratio of the Taxes (in constant 2015 US$) in Bhutan in 1999 to that in 2004?
Give a very brief answer. 0.54. What is the ratio of the Taxes (in constant 2015 US$) of Eritrea in 1999 to that in 2004?
Your answer should be compact. 0.67. What is the ratio of the Taxes (in constant 2015 US$) of Ethiopia in 1999 to that in 2004?
Give a very brief answer. 0.57. What is the ratio of the Taxes (in constant 2015 US$) in Netherlands in 1999 to that in 2004?
Provide a short and direct response. 0.65. What is the ratio of the Taxes (in constant 2015 US$) of Bhutan in 2000 to that in 2001?
Offer a terse response. 0.93. What is the ratio of the Taxes (in constant 2015 US$) in Eritrea in 2000 to that in 2001?
Offer a very short reply. 0.88. What is the ratio of the Taxes (in constant 2015 US$) in Ethiopia in 2000 to that in 2001?
Your answer should be compact. 0.9. What is the ratio of the Taxes (in constant 2015 US$) of Netherlands in 2000 to that in 2001?
Give a very brief answer. 0.91. What is the ratio of the Taxes (in constant 2015 US$) in Bhutan in 2000 to that in 2002?
Provide a short and direct response. 0.56. What is the ratio of the Taxes (in constant 2015 US$) in Eritrea in 2000 to that in 2002?
Provide a short and direct response. 0.63. What is the ratio of the Taxes (in constant 2015 US$) of Ethiopia in 2000 to that in 2002?
Your answer should be very brief. 0.95. What is the ratio of the Taxes (in constant 2015 US$) of Netherlands in 2000 to that in 2002?
Ensure brevity in your answer.  0.85. What is the ratio of the Taxes (in constant 2015 US$) in Bhutan in 2000 to that in 2003?
Your answer should be very brief. 0.48. What is the ratio of the Taxes (in constant 2015 US$) in Eritrea in 2000 to that in 2003?
Offer a terse response. 0.63. What is the ratio of the Taxes (in constant 2015 US$) of Ethiopia in 2000 to that in 2003?
Ensure brevity in your answer.  0.88. What is the ratio of the Taxes (in constant 2015 US$) in Netherlands in 2000 to that in 2003?
Provide a short and direct response. 0.7. What is the ratio of the Taxes (in constant 2015 US$) of Bhutan in 2000 to that in 2004?
Keep it short and to the point. 0.35. What is the ratio of the Taxes (in constant 2015 US$) of Eritrea in 2000 to that in 2004?
Keep it short and to the point. 0.5. What is the ratio of the Taxes (in constant 2015 US$) of Ethiopia in 2000 to that in 2004?
Your response must be concise. 0.62. What is the ratio of the Taxes (in constant 2015 US$) of Netherlands in 2000 to that in 2004?
Make the answer very short. 0.61. What is the ratio of the Taxes (in constant 2015 US$) of Bhutan in 2001 to that in 2002?
Provide a succinct answer. 0.61. What is the ratio of the Taxes (in constant 2015 US$) of Eritrea in 2001 to that in 2002?
Your answer should be compact. 0.71. What is the ratio of the Taxes (in constant 2015 US$) in Ethiopia in 2001 to that in 2002?
Provide a short and direct response. 1.06. What is the ratio of the Taxes (in constant 2015 US$) in Netherlands in 2001 to that in 2002?
Your response must be concise. 0.94. What is the ratio of the Taxes (in constant 2015 US$) of Bhutan in 2001 to that in 2003?
Your answer should be very brief. 0.52. What is the ratio of the Taxes (in constant 2015 US$) in Eritrea in 2001 to that in 2003?
Give a very brief answer. 0.71. What is the ratio of the Taxes (in constant 2015 US$) of Ethiopia in 2001 to that in 2003?
Your answer should be very brief. 0.98. What is the ratio of the Taxes (in constant 2015 US$) of Netherlands in 2001 to that in 2003?
Provide a succinct answer. 0.77. What is the ratio of the Taxes (in constant 2015 US$) in Bhutan in 2001 to that in 2004?
Ensure brevity in your answer.  0.38. What is the ratio of the Taxes (in constant 2015 US$) in Eritrea in 2001 to that in 2004?
Give a very brief answer. 0.56. What is the ratio of the Taxes (in constant 2015 US$) of Ethiopia in 2001 to that in 2004?
Provide a succinct answer. 0.69. What is the ratio of the Taxes (in constant 2015 US$) of Netherlands in 2001 to that in 2004?
Provide a succinct answer. 0.67. What is the ratio of the Taxes (in constant 2015 US$) of Bhutan in 2002 to that in 2003?
Offer a terse response. 0.85. What is the ratio of the Taxes (in constant 2015 US$) of Ethiopia in 2002 to that in 2003?
Keep it short and to the point. 0.92. What is the ratio of the Taxes (in constant 2015 US$) of Netherlands in 2002 to that in 2003?
Your answer should be very brief. 0.82. What is the ratio of the Taxes (in constant 2015 US$) of Bhutan in 2002 to that in 2004?
Your response must be concise. 0.63. What is the ratio of the Taxes (in constant 2015 US$) in Eritrea in 2002 to that in 2004?
Offer a terse response. 0.79. What is the ratio of the Taxes (in constant 2015 US$) of Ethiopia in 2002 to that in 2004?
Offer a terse response. 0.64. What is the ratio of the Taxes (in constant 2015 US$) of Netherlands in 2002 to that in 2004?
Give a very brief answer. 0.71. What is the ratio of the Taxes (in constant 2015 US$) in Bhutan in 2003 to that in 2004?
Provide a short and direct response. 0.74. What is the ratio of the Taxes (in constant 2015 US$) in Eritrea in 2003 to that in 2004?
Your response must be concise. 0.79. What is the ratio of the Taxes (in constant 2015 US$) of Ethiopia in 2003 to that in 2004?
Provide a succinct answer. 0.7. What is the ratio of the Taxes (in constant 2015 US$) of Netherlands in 2003 to that in 2004?
Your answer should be compact. 0.87. What is the difference between the highest and the second highest Taxes (in constant 2015 US$) in Bhutan?
Offer a very short reply. 6.97e+06. What is the difference between the highest and the second highest Taxes (in constant 2015 US$) of Eritrea?
Your answer should be compact. 1.88e+07. What is the difference between the highest and the second highest Taxes (in constant 2015 US$) of Ethiopia?
Your answer should be very brief. 2.58e+08. What is the difference between the highest and the second highest Taxes (in constant 2015 US$) of Netherlands?
Ensure brevity in your answer.  9.34e+09. What is the difference between the highest and the lowest Taxes (in constant 2015 US$) of Bhutan?
Give a very brief answer. 1.73e+07. What is the difference between the highest and the lowest Taxes (in constant 2015 US$) of Eritrea?
Offer a terse response. 4.50e+07. What is the difference between the highest and the lowest Taxes (in constant 2015 US$) in Ethiopia?
Give a very brief answer. 3.70e+08. What is the difference between the highest and the lowest Taxes (in constant 2015 US$) in Netherlands?
Your answer should be compact. 2.76e+1. 